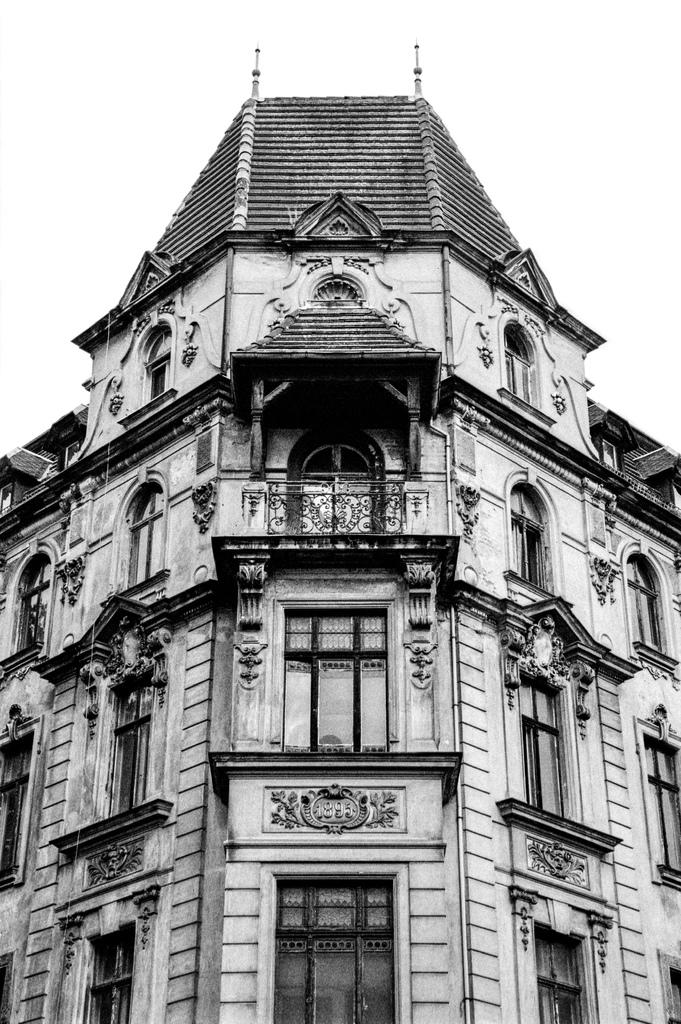What is the color scheme of the image? The image is black and white. What type of structure is visible in the image? There is a building in the image. What features can be seen on the building? The building has windows and doors. Is the queen present in the image, and if so, what is she doing? There is no queen present in the image. How does the growth of the building change throughout the day in the image? The image is black and white, and there is no indication of time or growth of the building. 